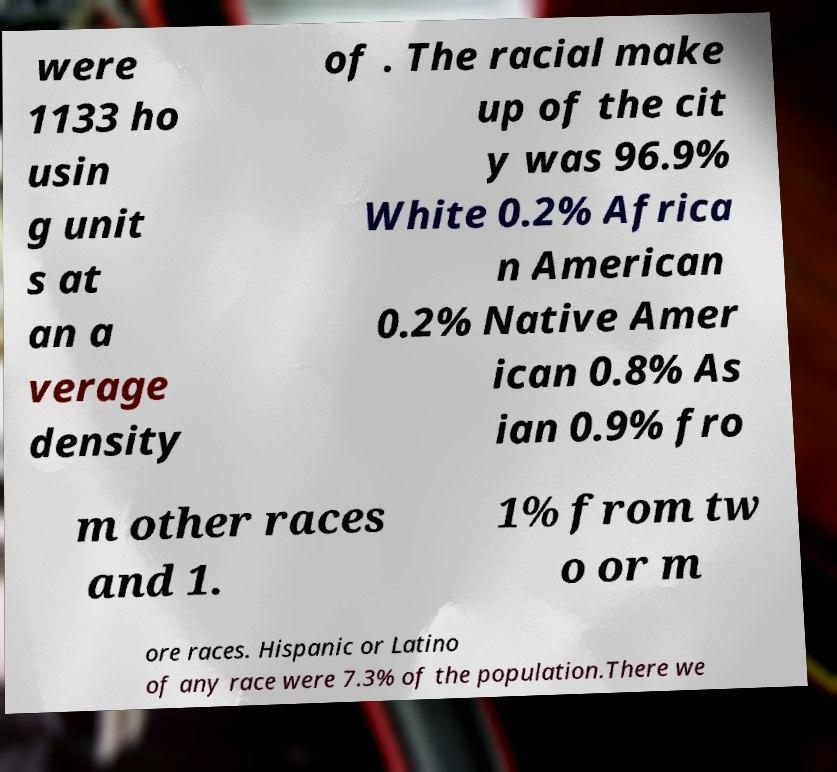Please read and relay the text visible in this image. What does it say? were 1133 ho usin g unit s at an a verage density of . The racial make up of the cit y was 96.9% White 0.2% Africa n American 0.2% Native Amer ican 0.8% As ian 0.9% fro m other races and 1. 1% from tw o or m ore races. Hispanic or Latino of any race were 7.3% of the population.There we 